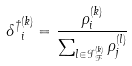<formula> <loc_0><loc_0><loc_500><loc_500>{ \delta ^ { \dagger } } ^ { ( k ) } _ { i } = \frac { \rho ^ { ( k ) } _ { i } } { \sum _ { l \in { \mathcal { I } } _ { \mathcal { F } } ^ { ( k ) } } \rho ^ { ( l ) } _ { j } }</formula> 